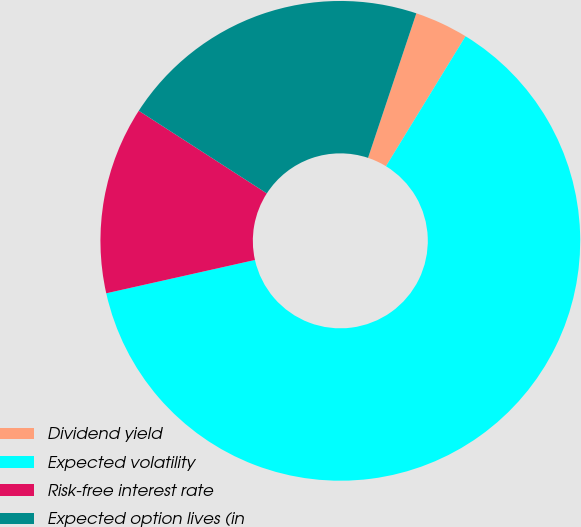Convert chart to OTSL. <chart><loc_0><loc_0><loc_500><loc_500><pie_chart><fcel>Dividend yield<fcel>Expected volatility<fcel>Risk-free interest rate<fcel>Expected option lives (in<nl><fcel>3.61%<fcel>62.75%<fcel>12.63%<fcel>21.01%<nl></chart> 